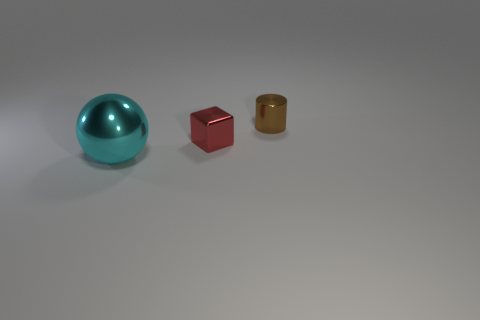Are there any tiny metal cylinders of the same color as the large object?
Give a very brief answer. No. What number of big balls have the same color as the tiny shiny block?
Provide a short and direct response. 0. What number of things are either metallic things in front of the cylinder or big cyan shiny spheres?
Provide a short and direct response. 2. What is the color of the tiny thing that is the same material as the cube?
Offer a very short reply. Brown. Are there any blocks that have the same size as the brown metal object?
Ensure brevity in your answer.  Yes. What number of things are either tiny metallic objects that are on the left side of the small brown metallic cylinder or things that are on the left side of the brown thing?
Ensure brevity in your answer.  2. There is a red metal thing that is the same size as the cylinder; what is its shape?
Provide a short and direct response. Cube. Is the number of metal cylinders less than the number of gray shiny objects?
Make the answer very short. No. There is a thing in front of the tiny red object; is its size the same as the metal object that is behind the small red block?
Offer a terse response. No. How many things are either cylinders or blue cylinders?
Provide a succinct answer. 1. 